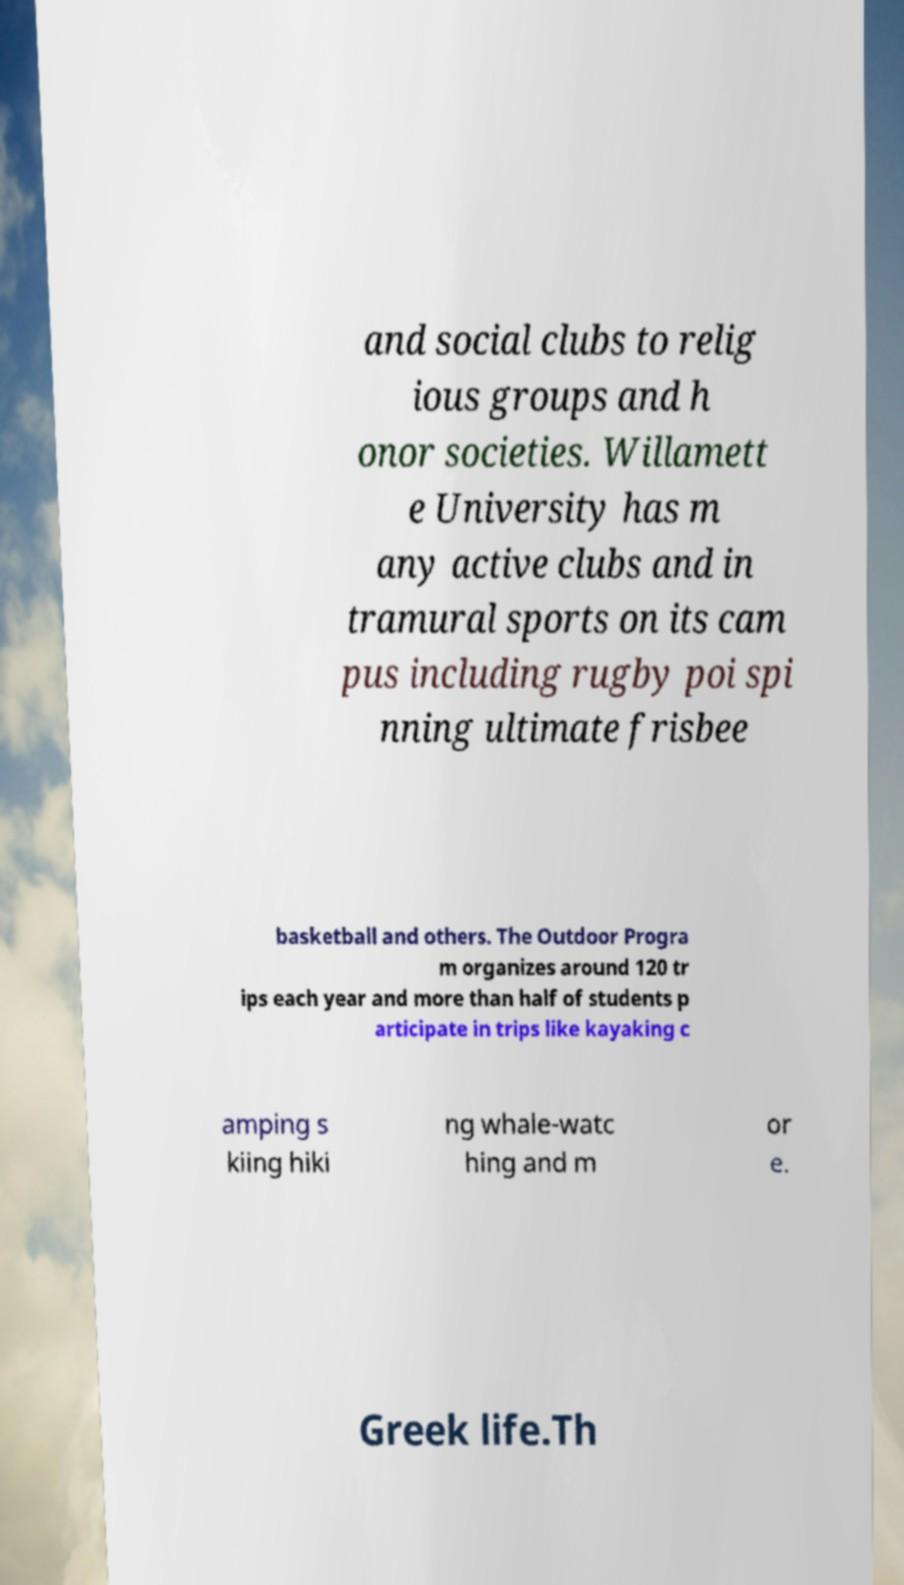For documentation purposes, I need the text within this image transcribed. Could you provide that? and social clubs to relig ious groups and h onor societies. Willamett e University has m any active clubs and in tramural sports on its cam pus including rugby poi spi nning ultimate frisbee basketball and others. The Outdoor Progra m organizes around 120 tr ips each year and more than half of students p articipate in trips like kayaking c amping s kiing hiki ng whale-watc hing and m or e. Greek life.Th 